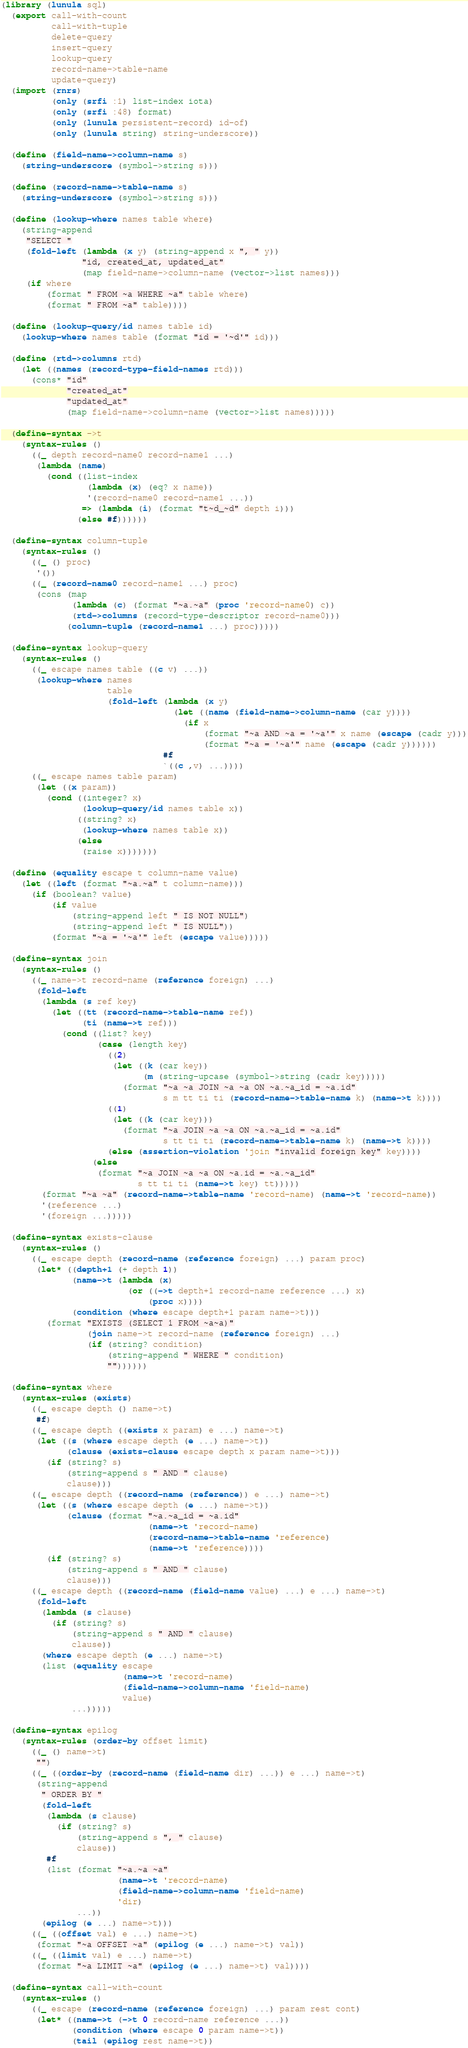<code> <loc_0><loc_0><loc_500><loc_500><_Scheme_>(library (lunula sql)
  (export call-with-count
          call-with-tuple
          delete-query
          insert-query
          lookup-query
          record-name->table-name
          update-query)
  (import (rnrs)
          (only (srfi :1) list-index iota)
          (only (srfi :48) format)
          (only (lunula persistent-record) id-of)
          (only (lunula string) string-underscore))

  (define (field-name->column-name s)
    (string-underscore (symbol->string s)))

  (define (record-name->table-name s)
    (string-underscore (symbol->string s)))

  (define (lookup-where names table where)
    (string-append
     "SELECT "
     (fold-left (lambda (x y) (string-append x ", " y))
                "id, created_at, updated_at"
                (map field-name->column-name (vector->list names)))
     (if where
         (format " FROM ~a WHERE ~a" table where)
         (format " FROM ~a" table))))

  (define (lookup-query/id names table id)
    (lookup-where names table (format "id = '~d'" id)))

  (define (rtd->columns rtd)
    (let ((names (record-type-field-names rtd)))
      (cons* "id"
             "created_at"
             "updated_at"
             (map field-name->column-name (vector->list names)))))

  (define-syntax ->t
    (syntax-rules ()
      ((_ depth record-name0 record-name1 ...)
       (lambda (name)
         (cond ((list-index
                 (lambda (x) (eq? x name))
                 '(record-name0 record-name1 ...))
                => (lambda (i) (format "t~d_~d" depth i)))
               (else #f))))))

  (define-syntax column-tuple
    (syntax-rules ()
      ((_ () proc)
       '())
      ((_ (record-name0 record-name1 ...) proc)
       (cons (map
              (lambda (c) (format "~a.~a" (proc 'record-name0) c))
              (rtd->columns (record-type-descriptor record-name0)))
             (column-tuple (record-name1 ...) proc)))))

  (define-syntax lookup-query
    (syntax-rules ()
      ((_ escape names table ((c v) ...))
       (lookup-where names
                     table
                     (fold-left (lambda (x y)
                                  (let ((name (field-name->column-name (car y))))
                                    (if x
                                        (format "~a AND ~a = '~a'" x name (escape (cadr y)))
                                        (format "~a = '~a'" name (escape (cadr y))))))
                                #f
                                `((c ,v) ...))))
      ((_ escape names table param)
       (let ((x param))
         (cond ((integer? x)
                (lookup-query/id names table x))
               ((string? x)
                (lookup-where names table x))
               (else
                (raise x)))))))

  (define (equality escape t column-name value)
    (let ((left (format "~a.~a" t column-name)))
      (if (boolean? value)
          (if value
              (string-append left " IS NOT NULL")
              (string-append left " IS NULL"))
          (format "~a = '~a'" left (escape value)))))

  (define-syntax join
    (syntax-rules ()
      ((_ name->t record-name (reference foreign) ...)
       (fold-left
        (lambda (s ref key)
          (let ((tt (record-name->table-name ref))
                (ti (name->t ref)))
            (cond ((list? key)
                   (case (length key)
                     ((2) 
                      (let ((k (car key))
                            (m (string-upcase (symbol->string (cadr key)))))
                        (format "~a ~a JOIN ~a ~a ON ~a.~a_id = ~a.id"
                                s m tt ti ti (record-name->table-name k) (name->t k))))
                     ((1)
                      (let ((k (car key)))
                        (format "~a JOIN ~a ~a ON ~a.~a_id = ~a.id"
                                s tt ti ti (record-name->table-name k) (name->t k))))
                     (else (assertion-violation 'join "invalid foreign key" key))))
                  (else
                   (format "~a JOIN ~a ~a ON ~a.id = ~a.~a_id"
                           s tt ti ti (name->t key) tt)))))
        (format "~a ~a" (record-name->table-name 'record-name) (name->t 'record-name))
        '(reference ...)
        '(foreign ...)))))

  (define-syntax exists-clause
    (syntax-rules ()
      ((_ escape depth (record-name (reference foreign) ...) param proc)
       (let* ((depth+1 (+ depth 1))
              (name->t (lambda (x)
                         (or ((->t depth+1 record-name reference ...) x)
                             (proc x))))
              (condition (where escape depth+1 param name->t)))
         (format "EXISTS (SELECT 1 FROM ~a~a)"
                 (join name->t record-name (reference foreign) ...)
                 (if (string? condition)
                     (string-append " WHERE " condition)
                     ""))))))

  (define-syntax where
    (syntax-rules (exists)
      ((_ escape depth () name->t)
       #f)
      ((_ escape depth ((exists x param) e ...) name->t)
       (let ((s (where escape depth (e ...) name->t))
             (clause (exists-clause escape depth x param name->t)))
         (if (string? s)
             (string-append s " AND " clause)
             clause)))
      ((_ escape depth ((record-name (reference)) e ...) name->t)
       (let ((s (where escape depth (e ...) name->t))
             (clause (format "~a.~a_id = ~a.id"
                             (name->t 'record-name)
                             (record-name->table-name 'reference)
                             (name->t 'reference))))
         (if (string? s)
             (string-append s " AND " clause)
             clause)))
      ((_ escape depth ((record-name (field-name value) ...) e ...) name->t)
       (fold-left
        (lambda (s clause)
          (if (string? s)
              (string-append s " AND " clause)
              clause))
        (where escape depth (e ...) name->t)
        (list (equality escape
                        (name->t 'record-name)
                        (field-name->column-name 'field-name)
                        value)
              ...)))))

  (define-syntax epilog
    (syntax-rules (order-by offset limit)
      ((_ () name->t)
       "")
      ((_ ((order-by (record-name (field-name dir) ...)) e ...) name->t)
       (string-append
        " ORDER BY "
        (fold-left
         (lambda (s clause)
           (if (string? s)
               (string-append s ", " clause)
               clause))
         #f
         (list (format "~a.~a ~a"
                       (name->t 'record-name)
                       (field-name->column-name 'field-name)
                       'dir)
               ...))
        (epilog (e ...) name->t)))
      ((_ ((offset val) e ...) name->t)
       (format "~a OFFSET ~a" (epilog (e ...) name->t) val))
      ((_ ((limit val) e ...) name->t)
       (format "~a LIMIT ~a" (epilog (e ...) name->t) val))))

  (define-syntax call-with-count
    (syntax-rules ()
      ((_ escape (record-name (reference foreign) ...) param rest cont)
       (let* ((name->t (->t 0 record-name reference ...))
              (condition (where escape 0 param name->t))
              (tail (epilog rest name->t))</code> 